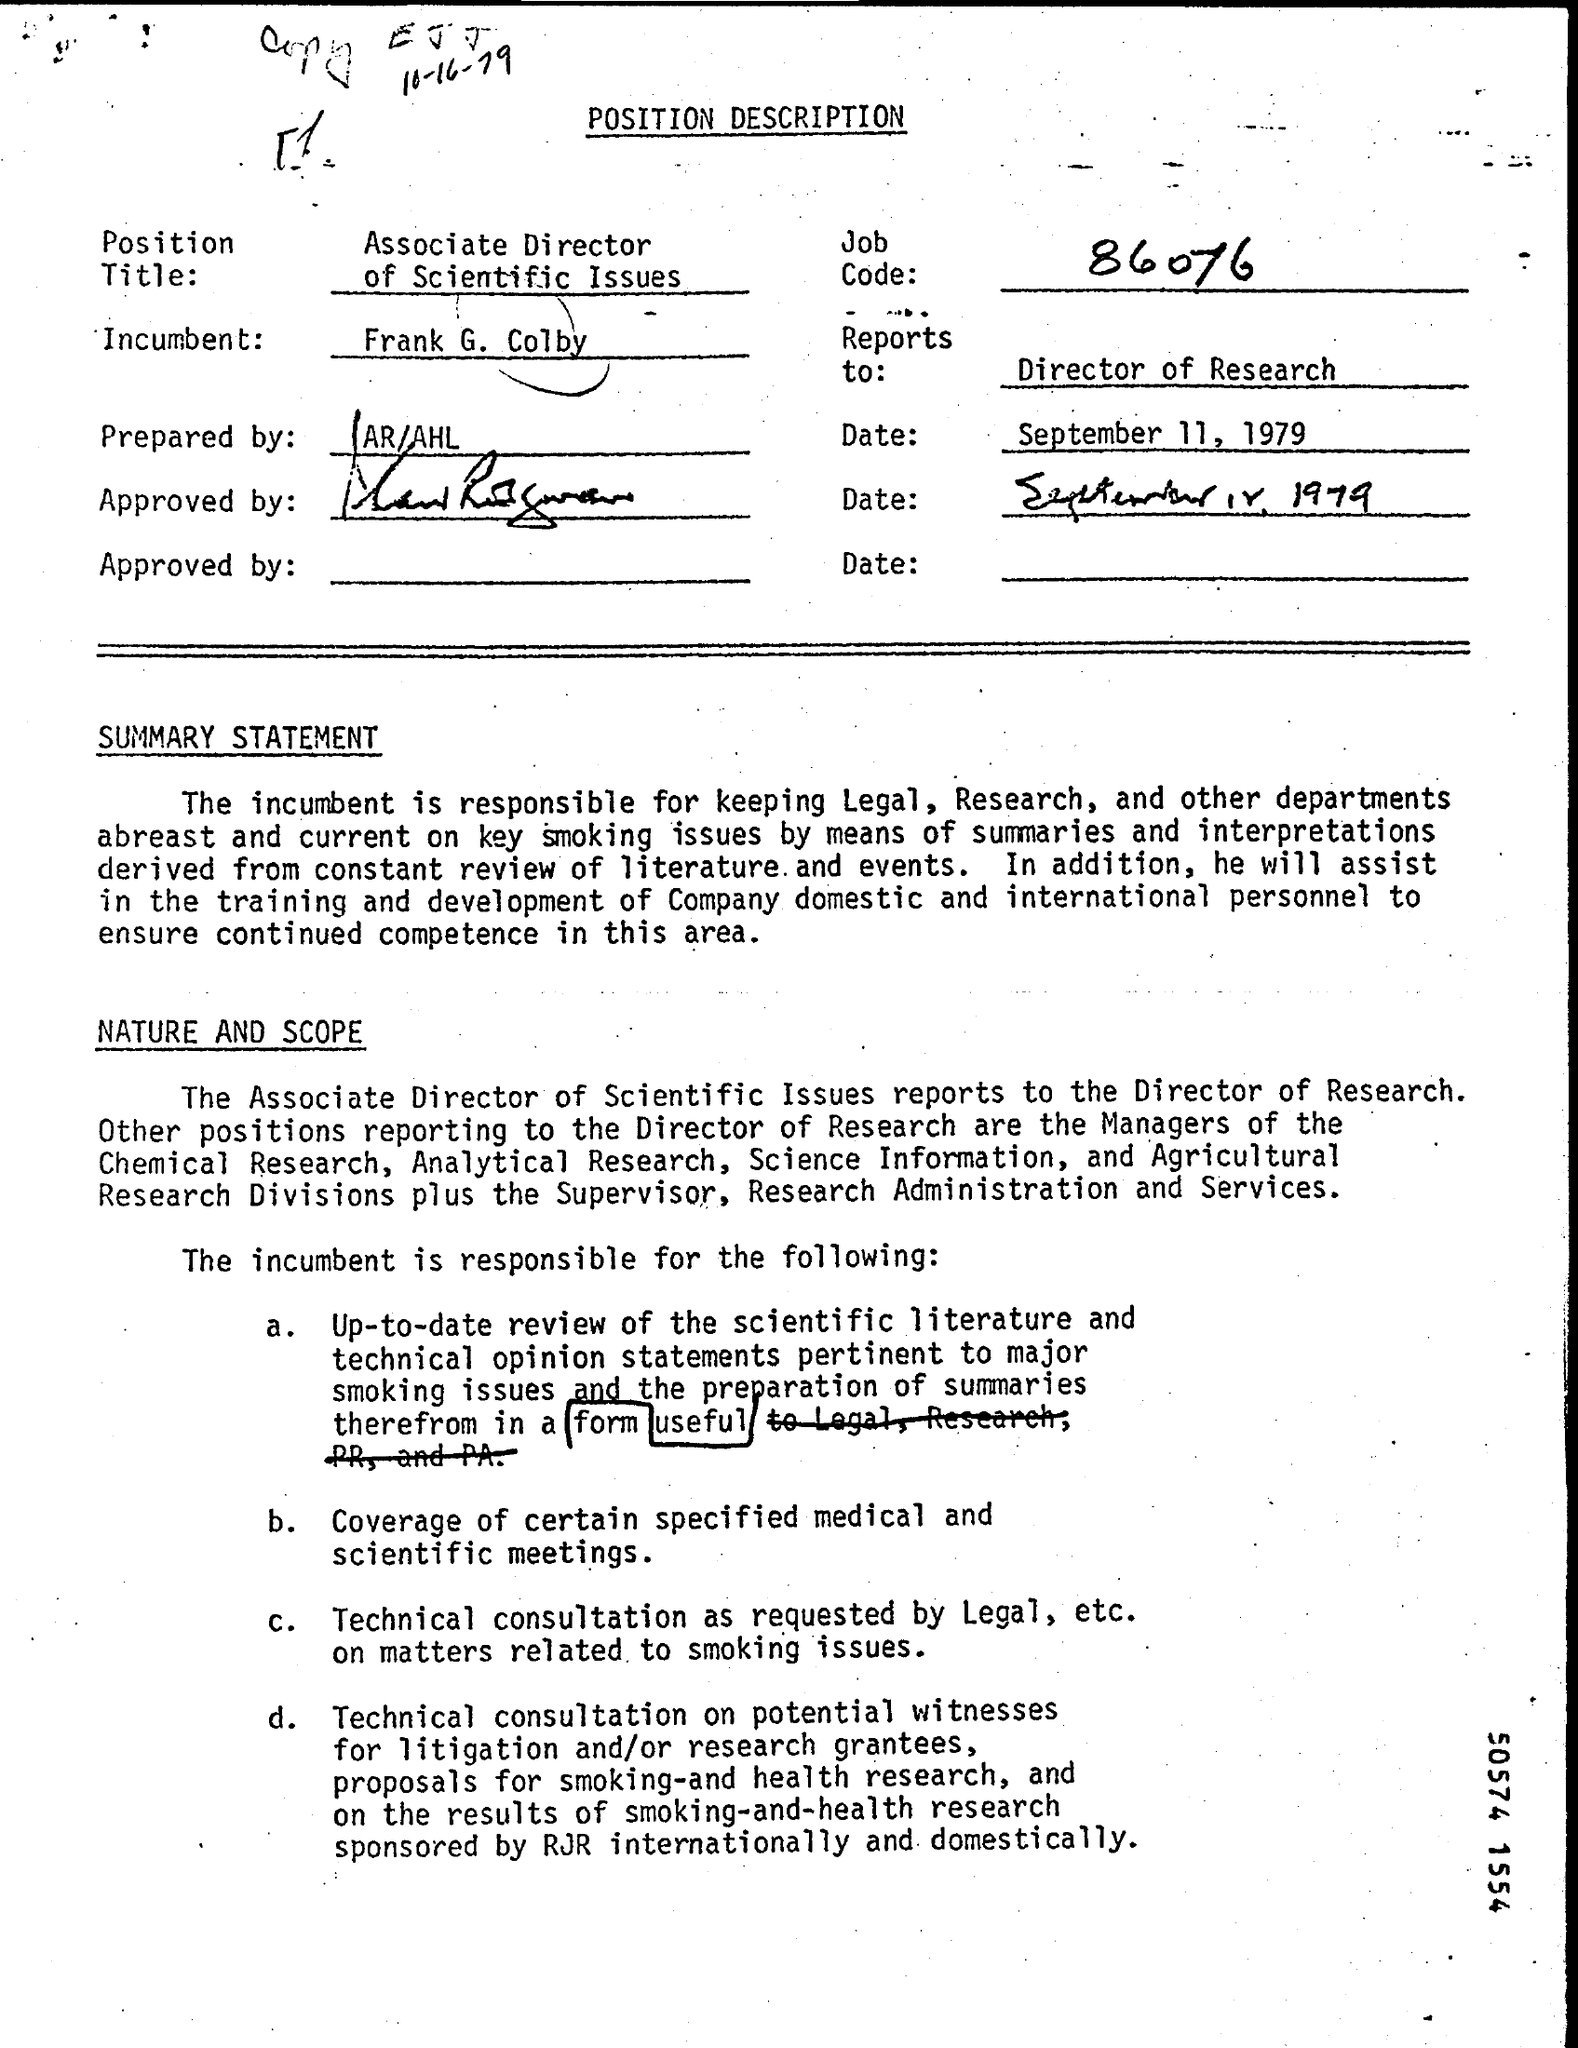Highlight a few significant elements in this photo. The job code number mentioned in the description is 86076. This position description was prepared by AR/AHL. The incumbent named in the position description is Frank G. Colby. 